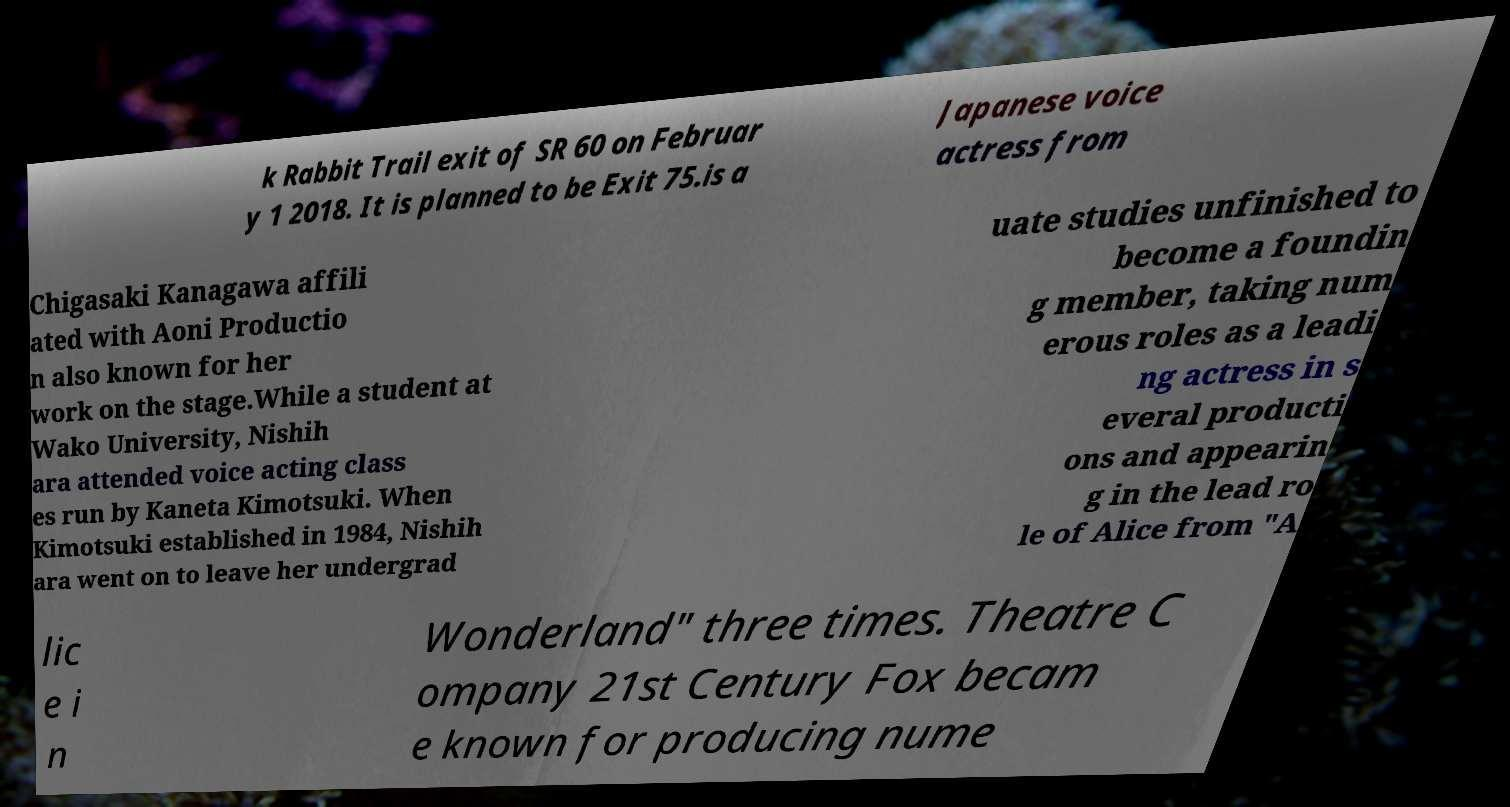I need the written content from this picture converted into text. Can you do that? k Rabbit Trail exit of SR 60 on Februar y 1 2018. It is planned to be Exit 75.is a Japanese voice actress from Chigasaki Kanagawa affili ated with Aoni Productio n also known for her work on the stage.While a student at Wako University, Nishih ara attended voice acting class es run by Kaneta Kimotsuki. When Kimotsuki established in 1984, Nishih ara went on to leave her undergrad uate studies unfinished to become a foundin g member, taking num erous roles as a leadi ng actress in s everal producti ons and appearin g in the lead ro le of Alice from "A lic e i n Wonderland" three times. Theatre C ompany 21st Century Fox becam e known for producing nume 